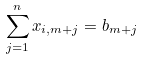<formula> <loc_0><loc_0><loc_500><loc_500>\sum _ { j = 1 } ^ { n } x _ { i , m + j } = b _ { m + j }</formula> 